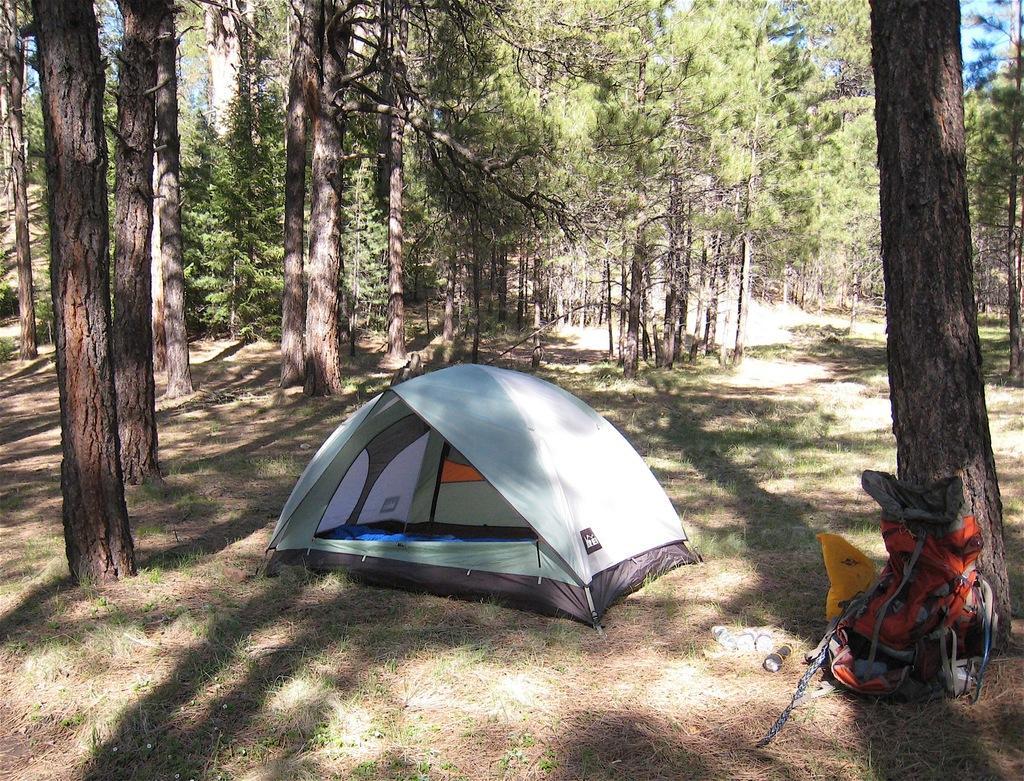Can you describe this image briefly? In this image I can see an open grass ground and on it I can see a tent house, shadows, number of trees and on the right side of this image I can see a bag and few other stuffs. I can also see the sky on the top right side of this image. 